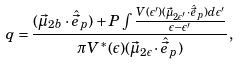Convert formula to latex. <formula><loc_0><loc_0><loc_500><loc_500>q = \frac { ( \vec { \mu } _ { 2 b } \cdot \hat { \vec { e } } _ { p } ) + P \int \frac { V ( \epsilon ^ { \prime } ) ( \vec { \mu } _ { 2 \epsilon ^ { \prime } } \cdot \hat { \vec { e } } _ { p } ) d \epsilon ^ { \prime } } { \epsilon - \epsilon ^ { \prime } } } { \pi V ^ { * } ( \epsilon ) ( \vec { \mu } _ { 2 \epsilon } \cdot \hat { \vec { e } } _ { p } ) } ,</formula> 